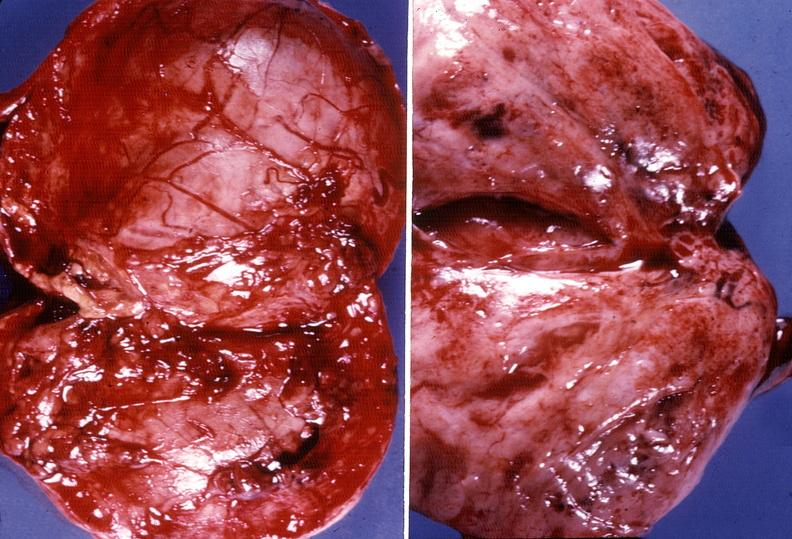what does this image show?
Answer the question using a single word or phrase. Adrenal phaeochromocytoma 